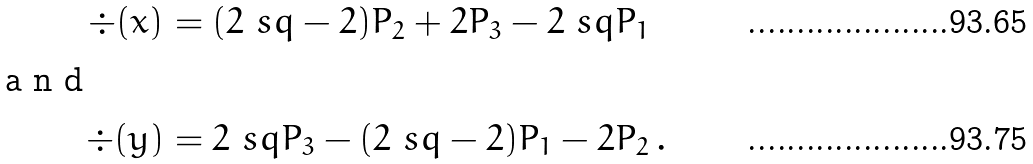<formula> <loc_0><loc_0><loc_500><loc_500>\div ( x ) & = ( 2 \ s q - 2 ) P _ { 2 } + 2 P _ { 3 } - 2 \ s q P _ { 1 } \\ \intertext { a n d } \div ( y ) & = 2 \ s q P _ { 3 } - ( 2 \ s q - 2 ) P _ { 1 } - 2 P _ { 2 } \, .</formula> 